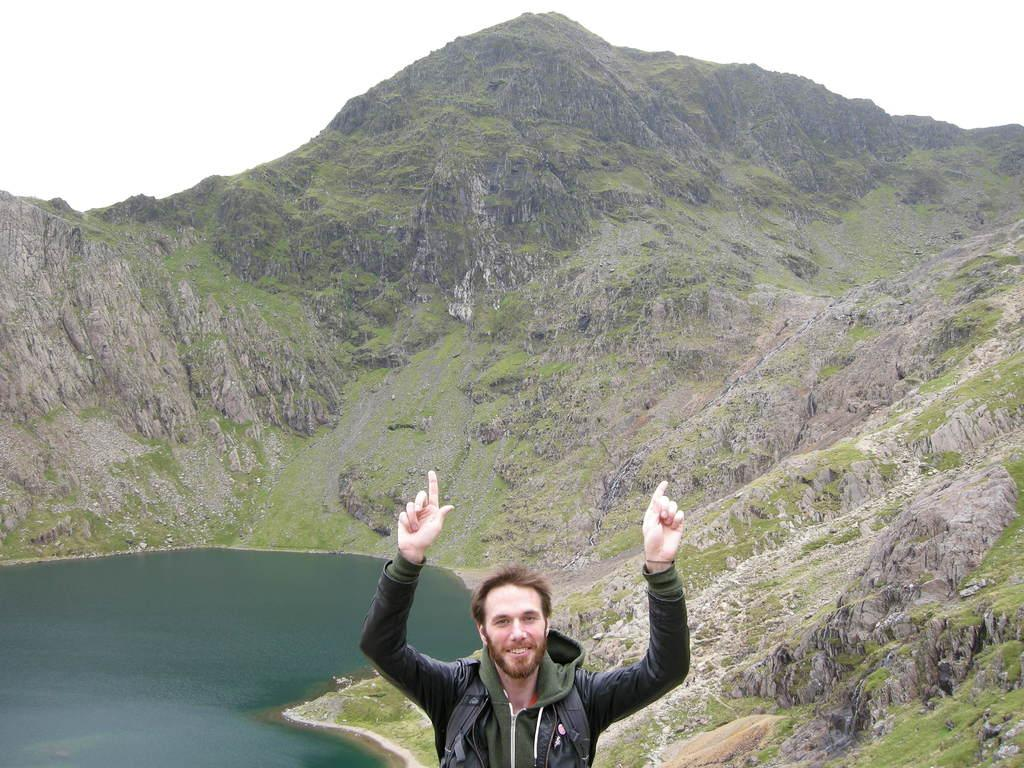Who or what is the main subject in the image? There is a person in the image. What is the person wearing? The person is wearing a black and green dress. What can be seen to the left of the person? There is water visible to the left of the person. What is visible in the background of the image? There is a mountain and the sky visible in the background of the image. What type of unit is being discussed by the governor in the image? There is no governor or unit present in the image; it features a person in a black and green dress standing near water with a mountain and the sky visible in the background. Is there a church visible in the image? No, there is no church present in the image. 